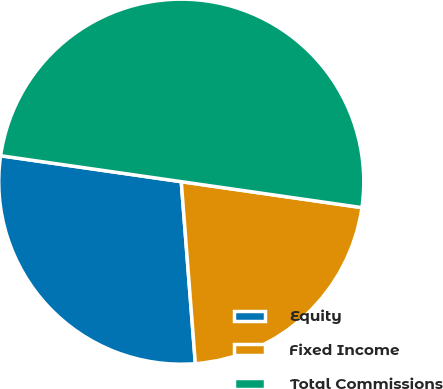<chart> <loc_0><loc_0><loc_500><loc_500><pie_chart><fcel>Equity<fcel>Fixed Income<fcel>Total Commissions<nl><fcel>28.5%<fcel>21.5%<fcel>50.0%<nl></chart> 